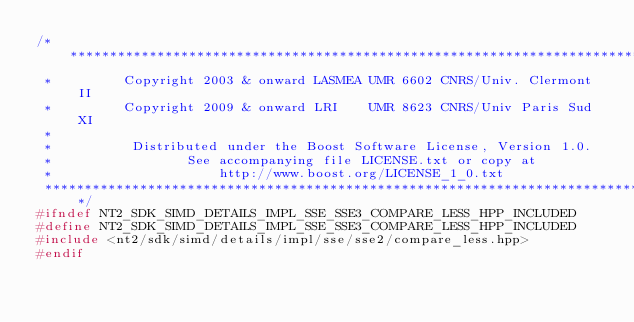Convert code to text. <code><loc_0><loc_0><loc_500><loc_500><_C++_>/*******************************************************************************
 *         Copyright 2003 & onward LASMEA UMR 6602 CNRS/Univ. Clermont II
 *         Copyright 2009 & onward LRI    UMR 8623 CNRS/Univ Paris Sud XI
 *
 *          Distributed under the Boost Software License, Version 1.0.
 *                 See accompanying file LICENSE.txt or copy at
 *                     http://www.boost.org/LICENSE_1_0.txt
 ******************************************************************************/
#ifndef NT2_SDK_SIMD_DETAILS_IMPL_SSE_SSE3_COMPARE_LESS_HPP_INCLUDED
#define NT2_SDK_SIMD_DETAILS_IMPL_SSE_SSE3_COMPARE_LESS_HPP_INCLUDED
#include <nt2/sdk/simd/details/impl/sse/sse2/compare_less.hpp>
#endif
</code> 